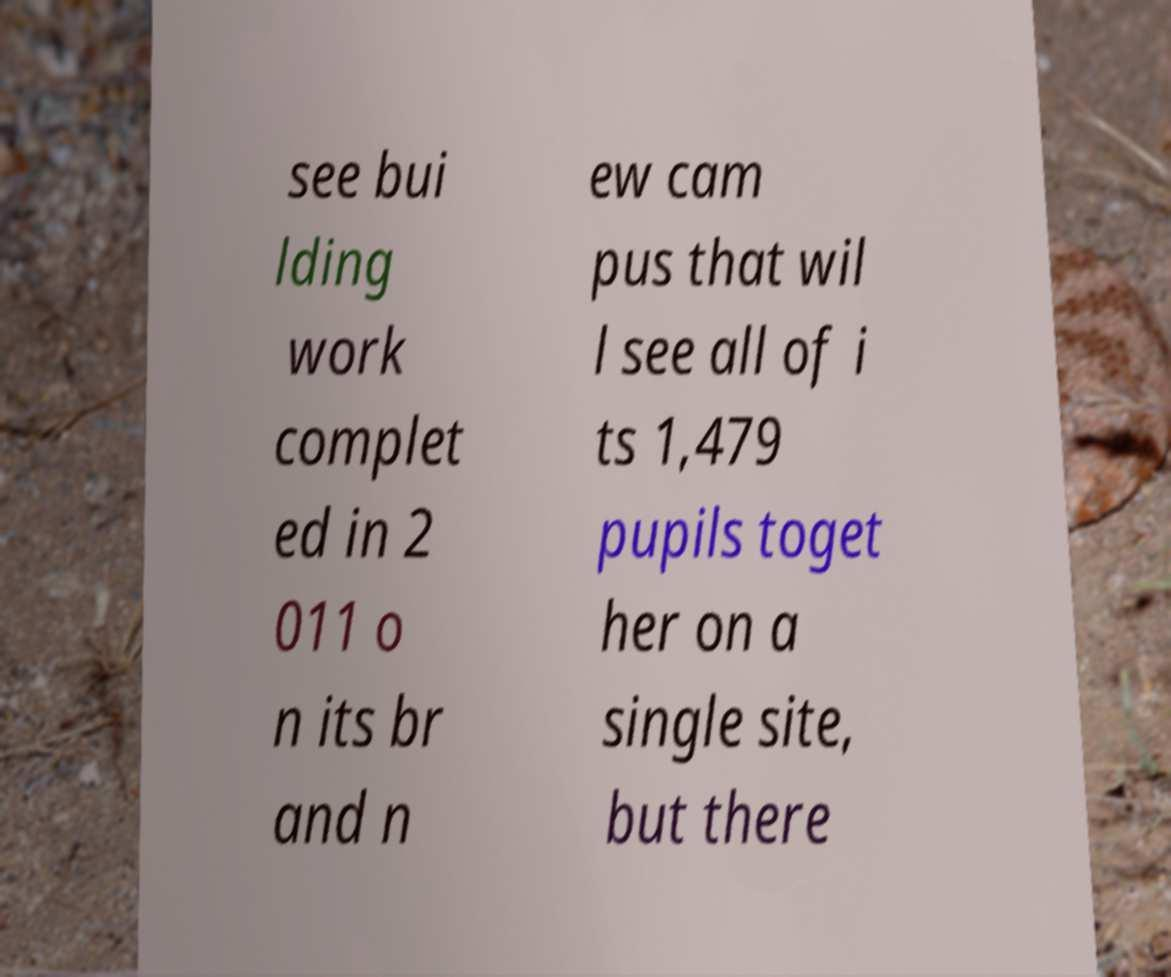For documentation purposes, I need the text within this image transcribed. Could you provide that? see bui lding work complet ed in 2 011 o n its br and n ew cam pus that wil l see all of i ts 1,479 pupils toget her on a single site, but there 